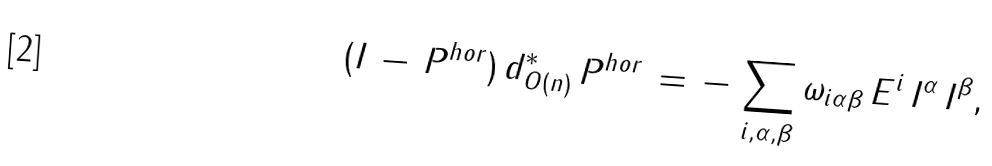<formula> <loc_0><loc_0><loc_500><loc_500>( I \, - \, P ^ { h o r } ) \, d ^ { * } _ { O ( n ) } \, P ^ { h o r } \, = \, - \, \sum _ { i , \alpha , \beta } \omega _ { i \alpha \beta } \, E ^ { i } \, I ^ { \alpha } \, I ^ { \beta } ,</formula> 